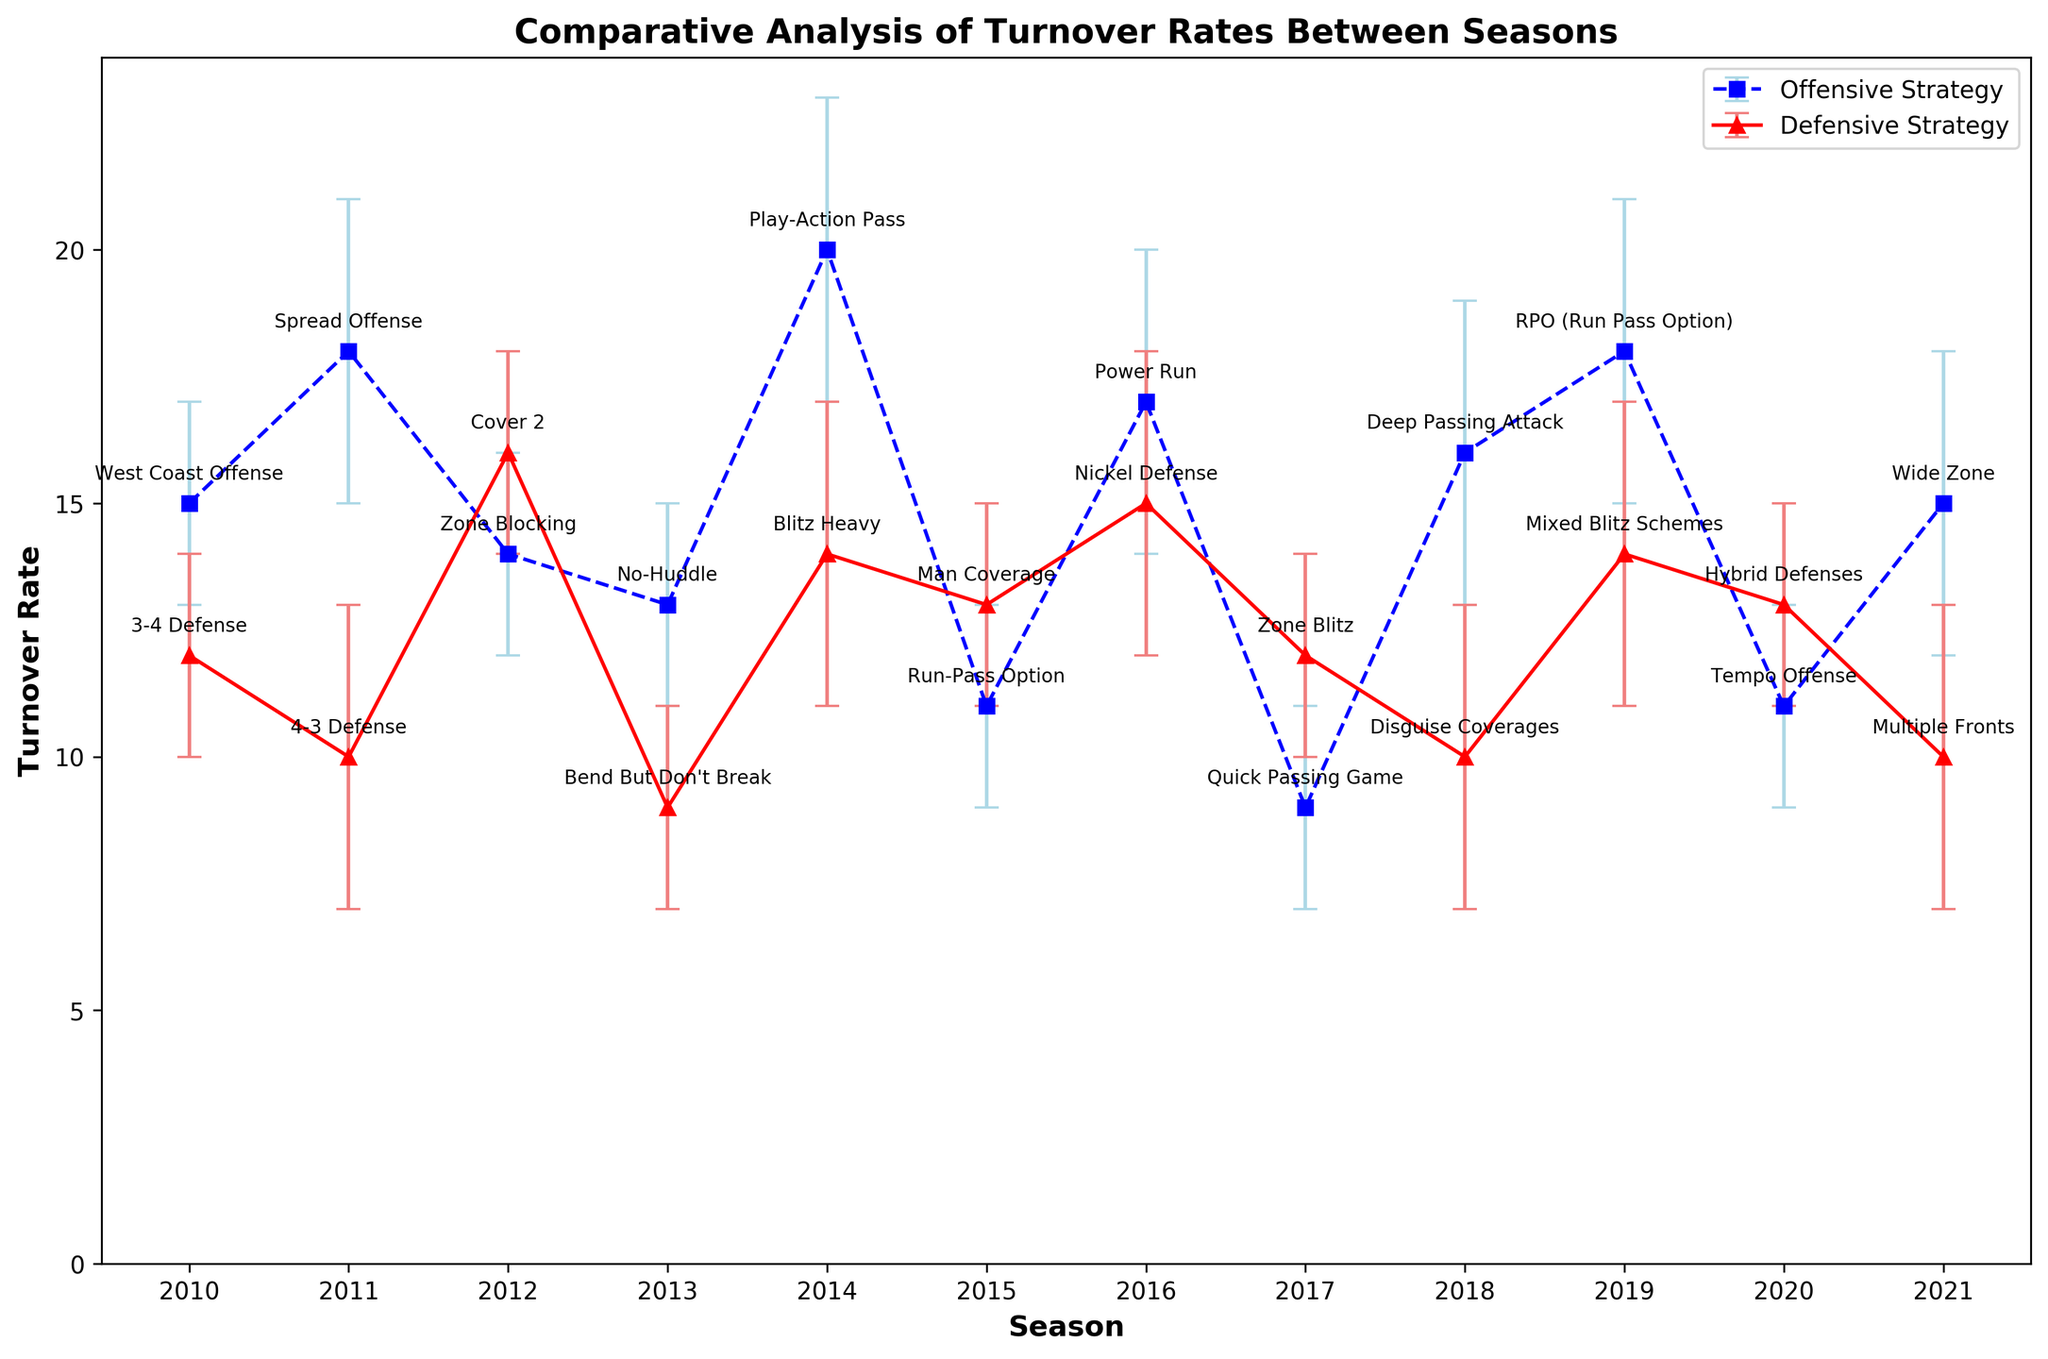What season had the highest offensive turnover rate and what strategy was used that year? In the figure, look for the highest point on the blue dashed line (offensive strategy). The highest turnover rate in the offensive strategy data points corresponds to the 2014 season. The label next to this point indicates the use of the "Play-Action Pass" strategy.
Answer: 2014, Play-Action Pass Comparing defensive strategies, which season had the lowest turnover rate and what strategy was used? Examine the red solid line (defensive strategy) for the lowest point. The minimum turnover rate in the defensive strategy data points corresponds to the 2013 season. The label next to this point indicates the "Bend But Don't Break" strategy.
Answer: 2013, Bend But Don't Break In which seasons did offensive and defensive turnover rates both have error bars of 3? Look at the error bars in the figure. Specifically, identify the seasons where both offensive and defensive turnover rates are represented with error bars of 3. These seasons are 2011, 2014, 2016, 2018, and 2021, as both lines have the same error bar size.
Answer: 2011, 2014, 2016, 2018, 2021 What's the average turnover rate for defensive strategies across all seasons? Sum up all the turnover rates for the defensive strategies: 2010 (14) + 2011 (10) + 2012 (16) + 2013 (9) + 2014 (14) + 2015 (13) + 2016 (15) + 2017 (12) + 2018 (10) + 2019 (14) + 2020 (13) + 2021 (10). There are 12 seasons in total. The average is calculated as (14 + 10 + 16 + 9 + 14 + 13 + 15 + 12 + 10 + 14 + 13 + 10) / 12 = 150 / 12.
Answer: 12.5 How does the turnover rate in the 2017 offensive strategy compare to the 2017 defensive strategy? Check the turnover rates for both offensive and defensive strategies in the 2017 season. The offensive strategy had a turnover rate of 9, and the defensive strategy had a turnover rate of 12. The offensive turnover rate is lower than the defensive turnover rate.
Answer: Offensive is lower What is the difference in turnover rates between the highest and lowest points in defensive strategies? Identify the highest and lowest points on the red solid line. The highest point is in 2012 with a turnover rate of 16, and the lowest point is in 2013 with a turnover rate of 9. The difference is 16 - 9.
Answer: 7 Which strategy type tends to have higher turnover rates based on the data? Observe the general trend lines for the blue dashed line (offensive) and the red solid line (defensive). Notice if one generally sits higher than the other. The offensive strategies tend to have higher turnover rates compared to defensive strategies.
Answer: Offensive What's the difference in turnover rate for the "Run-Pass Option" strategy between 2015 and 2019? Locate the "Run-Pass Option" strategy points in the 2015 and 2019 seasons. In 2015, the turnover rate is 11, and in 2019, the turnover rate is 18. The difference is 18 - 11.
Answer: 7 